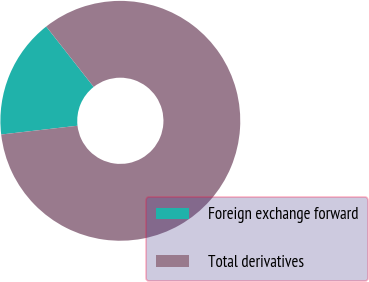<chart> <loc_0><loc_0><loc_500><loc_500><pie_chart><fcel>Foreign exchange forward<fcel>Total derivatives<nl><fcel>16.22%<fcel>83.78%<nl></chart> 